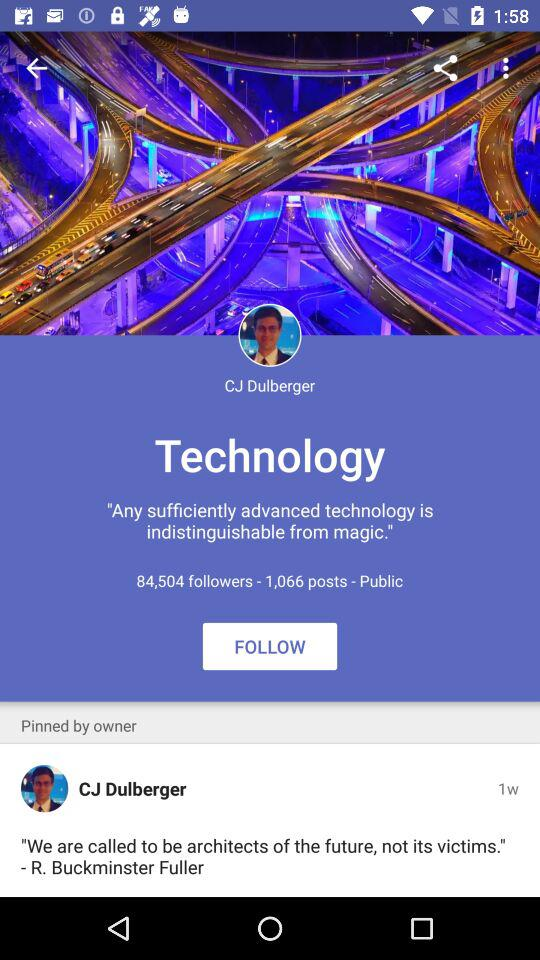When is the profile last updated?
When the provided information is insufficient, respond with <no answer>. <no answer> 